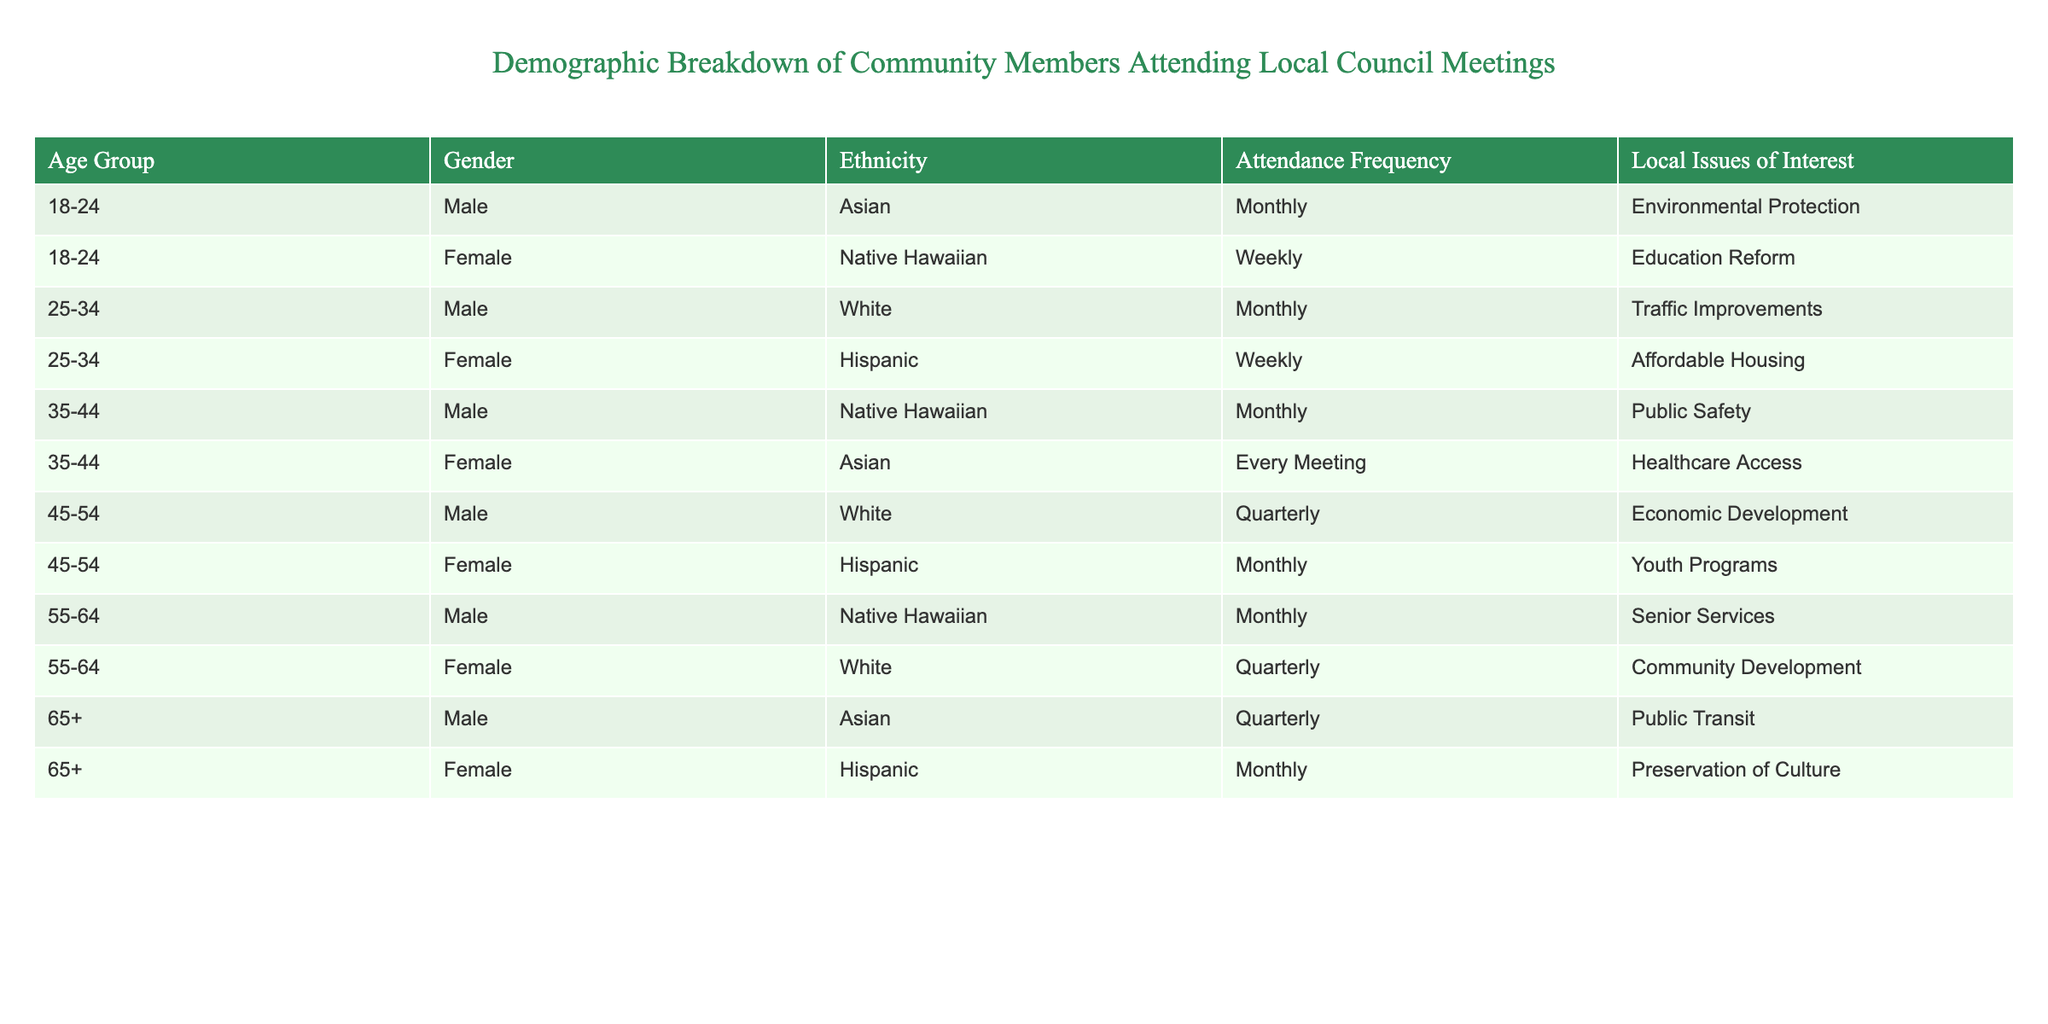What is the attendance frequency of the youngest age group? The youngest age group is 18-24 years old. In the table, there are two entries for this age group: one for Male with Monthly attendance and one for Female with Weekly attendance. Thus, the answer combines these two different attendance frequencies.
Answer: Monthly and Weekly How many female community members attend every meeting? There is one entry that specifies attendance every meeting in the table: for the age group 35-44, Female, Asian. Therefore, the count of female community members attending every meeting is just this one entry.
Answer: 1 Which ethnicity has the highest frequency of attendance at local council meetings? To find the ethnicity with the highest frequency, we examine the attendance categories. The frequency levels are: Every Meeting, Weekly, Monthly, Quarterly. The only entry with "Every Meeting" is the Female, Asian in the age group 35-44. Thus, Asian is the ethnicity with the highest frequency attendance.
Answer: Asian Is there any Male community member over the age of 55 interested in Education Reform? Looking through the data, we find no Male entries in the age group over 55 that lists Education Reform as an interest. The nearest entries are for males aged 55-64 and 65+, but neither lists Education Reform. Therefore, the answer is no.
Answer: No What is the average attendance frequency for the age group 45-54? In the data for the age group 45-54, there are two attendance frequencies: one for Male with Quarterly and one for Female with Monthly. We convert these to numerical values: Monthly = 3, Quarterly = 1. The average is calculated as (3 + 1) / 2 = 2, which corresponds to "Bi-Monthly". Hence, the average attendance frequency for this age group is computed as follows: sum of frequencies is 2, divided by the count of entries (2) gives us the average of 2.
Answer: Bi-Monthly Which local issue is of interest to the oldest age group? The age group 65+ has two entries: one Male interested in Public Transit and one Female interested in Preservation of Culture. The question is about what local issues this age group cares about, and both are listed. Therefore, we cite both issues of interest.
Answer: Public Transit, Preservation of Culture 